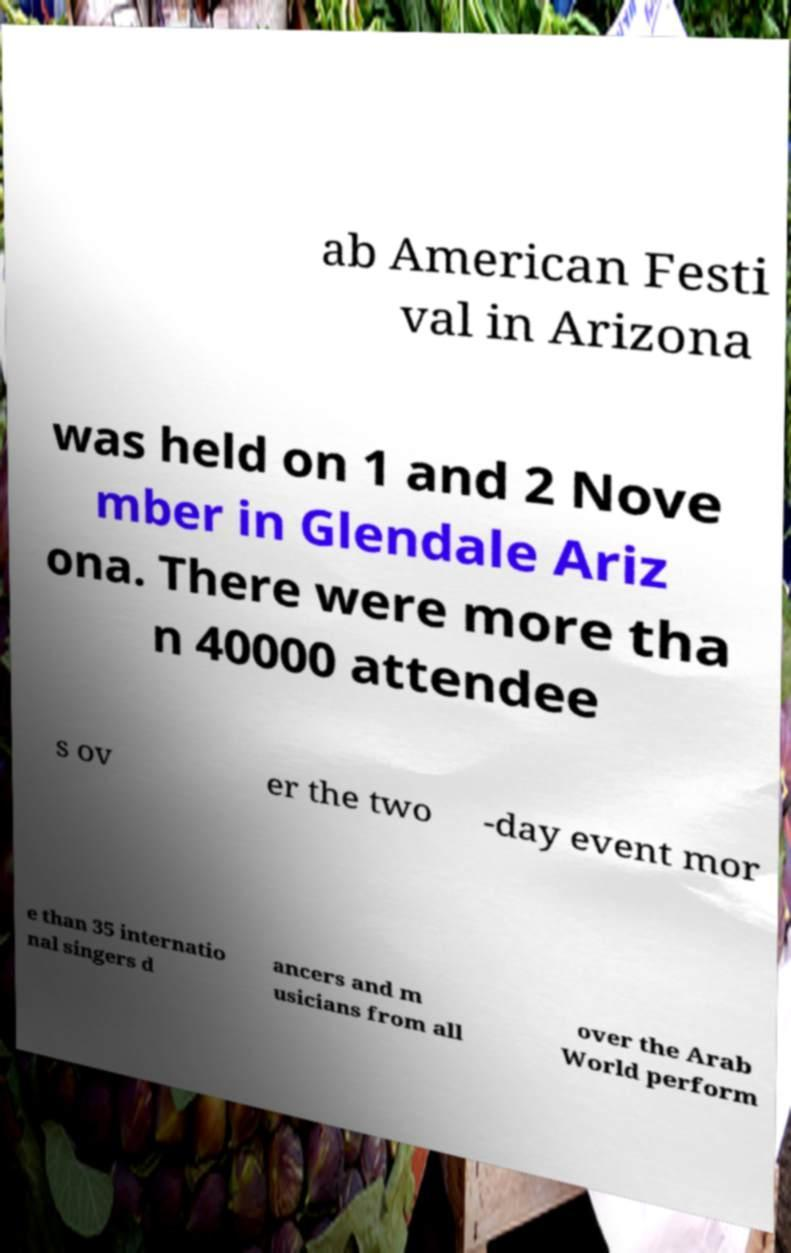For documentation purposes, I need the text within this image transcribed. Could you provide that? ab American Festi val in Arizona was held on 1 and 2 Nove mber in Glendale Ariz ona. There were more tha n 40000 attendee s ov er the two -day event mor e than 35 internatio nal singers d ancers and m usicians from all over the Arab World perform 